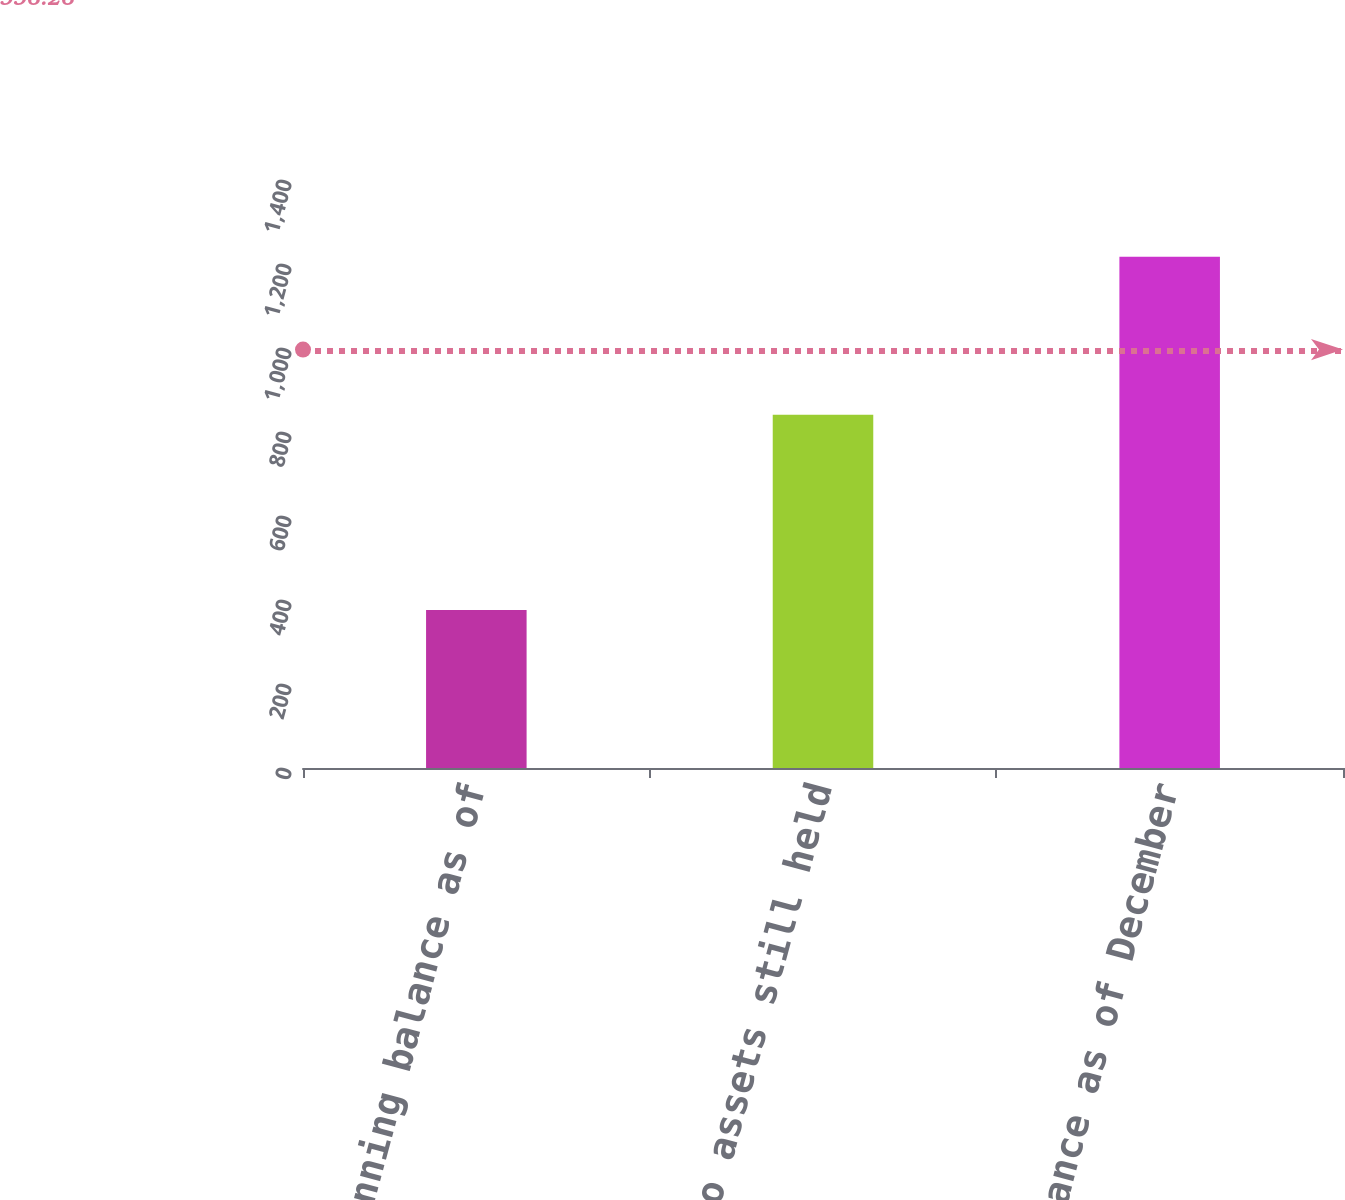Convert chart. <chart><loc_0><loc_0><loc_500><loc_500><bar_chart><fcel>Beginning balance as of<fcel>Relating to assets still held<fcel>Ending balance as of December<nl><fcel>376<fcel>841<fcel>1217<nl></chart> 